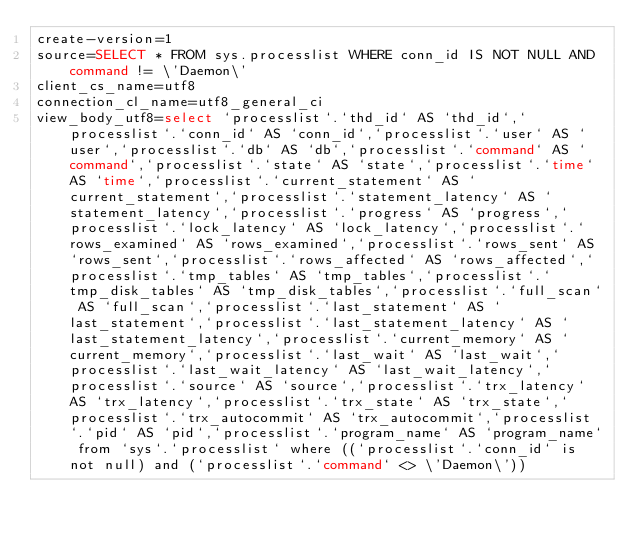Convert code to text. <code><loc_0><loc_0><loc_500><loc_500><_VisualBasic_>create-version=1
source=SELECT * FROM sys.processlist WHERE conn_id IS NOT NULL AND command != \'Daemon\'
client_cs_name=utf8
connection_cl_name=utf8_general_ci
view_body_utf8=select `processlist`.`thd_id` AS `thd_id`,`processlist`.`conn_id` AS `conn_id`,`processlist`.`user` AS `user`,`processlist`.`db` AS `db`,`processlist`.`command` AS `command`,`processlist`.`state` AS `state`,`processlist`.`time` AS `time`,`processlist`.`current_statement` AS `current_statement`,`processlist`.`statement_latency` AS `statement_latency`,`processlist`.`progress` AS `progress`,`processlist`.`lock_latency` AS `lock_latency`,`processlist`.`rows_examined` AS `rows_examined`,`processlist`.`rows_sent` AS `rows_sent`,`processlist`.`rows_affected` AS `rows_affected`,`processlist`.`tmp_tables` AS `tmp_tables`,`processlist`.`tmp_disk_tables` AS `tmp_disk_tables`,`processlist`.`full_scan` AS `full_scan`,`processlist`.`last_statement` AS `last_statement`,`processlist`.`last_statement_latency` AS `last_statement_latency`,`processlist`.`current_memory` AS `current_memory`,`processlist`.`last_wait` AS `last_wait`,`processlist`.`last_wait_latency` AS `last_wait_latency`,`processlist`.`source` AS `source`,`processlist`.`trx_latency` AS `trx_latency`,`processlist`.`trx_state` AS `trx_state`,`processlist`.`trx_autocommit` AS `trx_autocommit`,`processlist`.`pid` AS `pid`,`processlist`.`program_name` AS `program_name` from `sys`.`processlist` where ((`processlist`.`conn_id` is not null) and (`processlist`.`command` <> \'Daemon\'))
</code> 